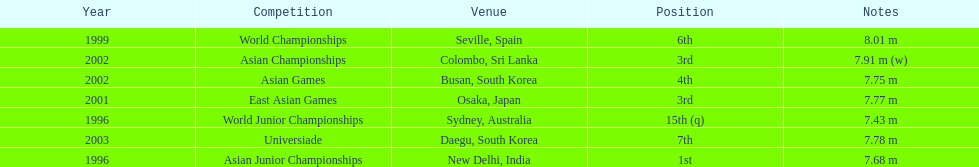I'm looking to parse the entire table for insights. Could you assist me with that? {'header': ['Year', 'Competition', 'Venue', 'Position', 'Notes'], 'rows': [['1999', 'World Championships', 'Seville, Spain', '6th', '8.01 m'], ['2002', 'Asian Championships', 'Colombo, Sri Lanka', '3rd', '7.91 m (w)'], ['2002', 'Asian Games', 'Busan, South Korea', '4th', '7.75 m'], ['2001', 'East Asian Games', 'Osaka, Japan', '3rd', '7.77 m'], ['1996', 'World Junior Championships', 'Sydney, Australia', '15th (q)', '7.43 m'], ['2003', 'Universiade', 'Daegu, South Korea', '7th', '7.78 m'], ['1996', 'Asian Junior Championships', 'New Delhi, India', '1st', '7.68 m']]} Which year was his best jump? 1999. 